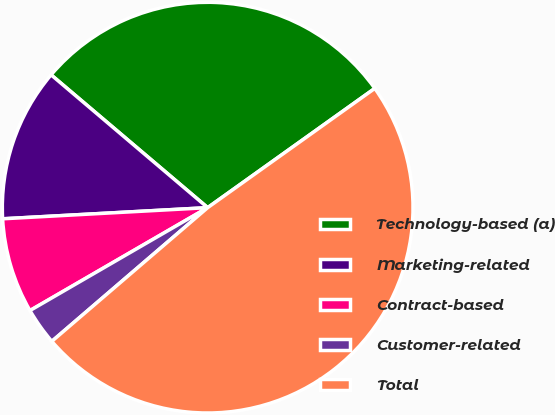Convert chart to OTSL. <chart><loc_0><loc_0><loc_500><loc_500><pie_chart><fcel>Technology-based (a)<fcel>Marketing-related<fcel>Contract-based<fcel>Customer-related<fcel>Total<nl><fcel>28.94%<fcel>12.06%<fcel>7.49%<fcel>2.93%<fcel>48.58%<nl></chart> 